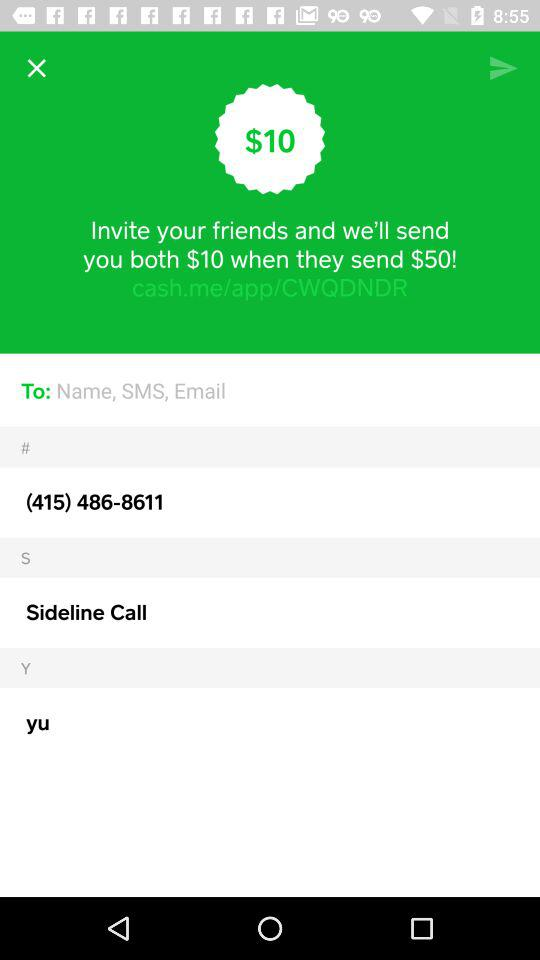How many dollars more does the user need to send to their friend to receive the $10 bonus?
Answer the question using a single word or phrase. 50 